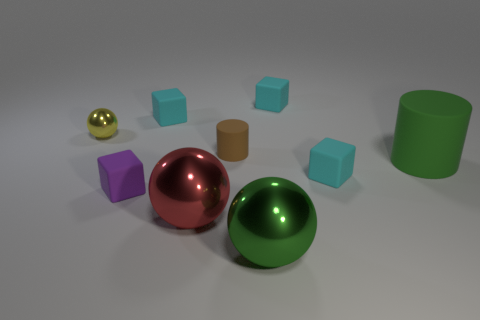How does the lighting in the scene affect the appearance of the objects? The lighting creates subtle shadows and highlights on the objects, enhancing their three-dimensional appearance. The shiny surfaces, like the spheres and the cylinder, reflect the light strongly and have bright highlights, whereas the matte objects diffuse the light, giving a softer look. 